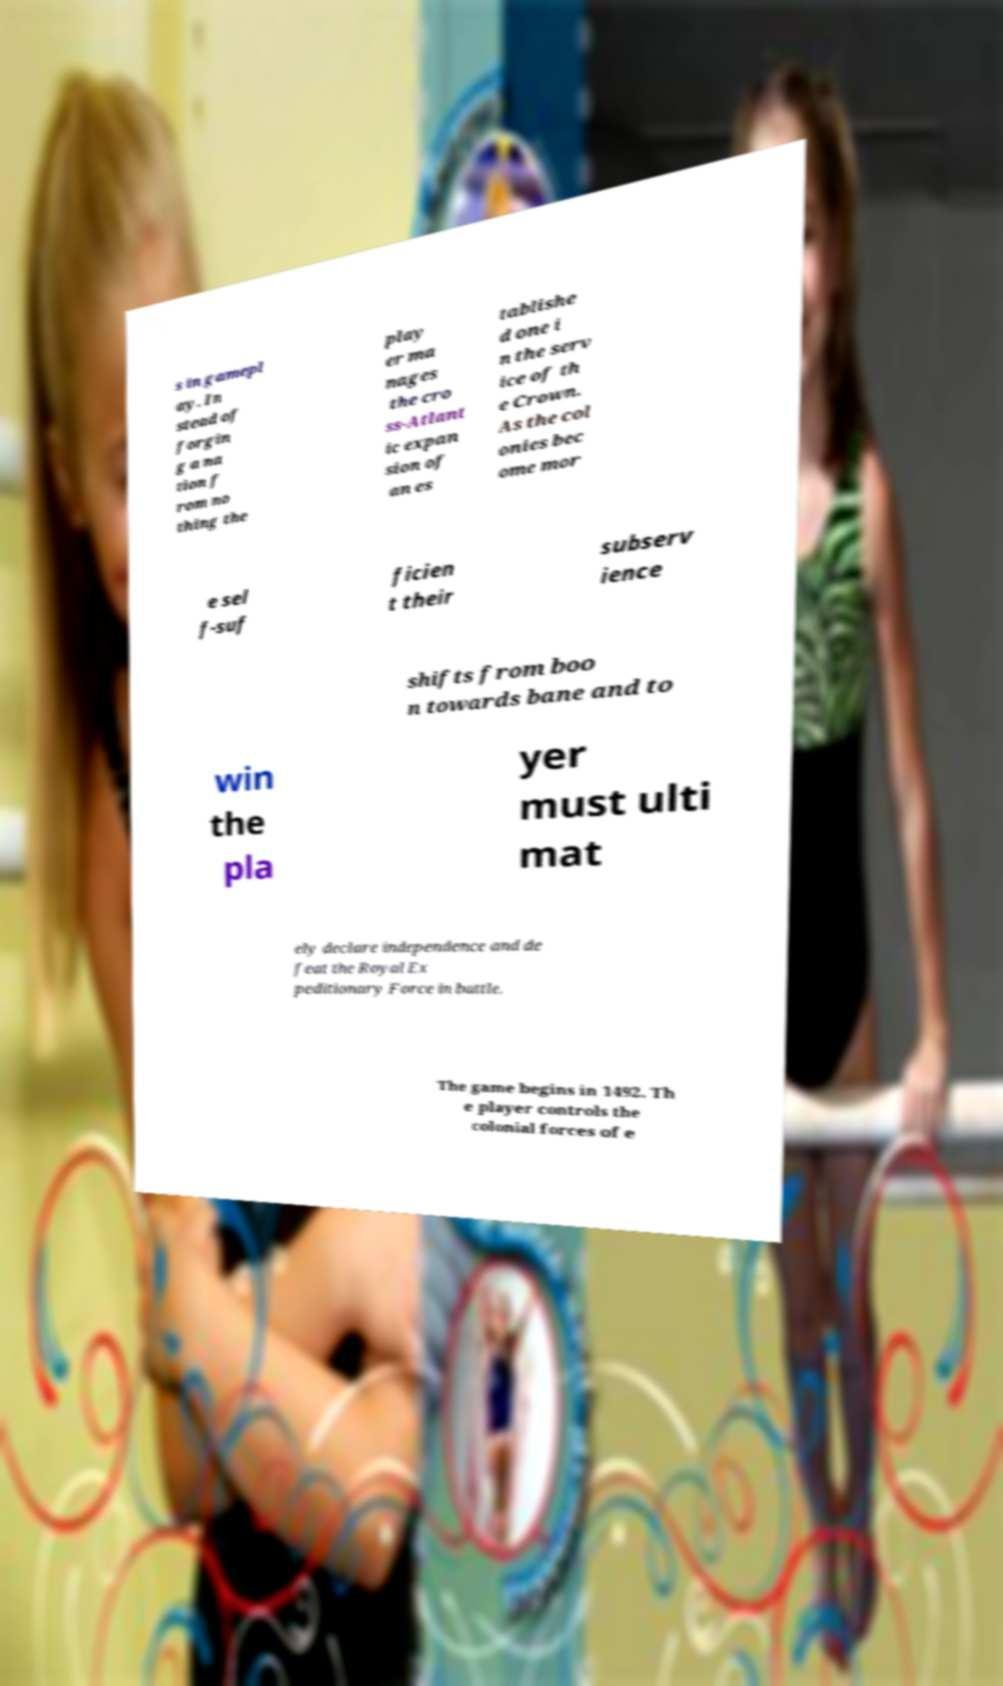Can you read and provide the text displayed in the image?This photo seems to have some interesting text. Can you extract and type it out for me? s in gamepl ay. In stead of forgin g a na tion f rom no thing the play er ma nages the cro ss-Atlant ic expan sion of an es tablishe d one i n the serv ice of th e Crown. As the col onies bec ome mor e sel f-suf ficien t their subserv ience shifts from boo n towards bane and to win the pla yer must ulti mat ely declare independence and de feat the Royal Ex peditionary Force in battle. The game begins in 1492. Th e player controls the colonial forces of e 